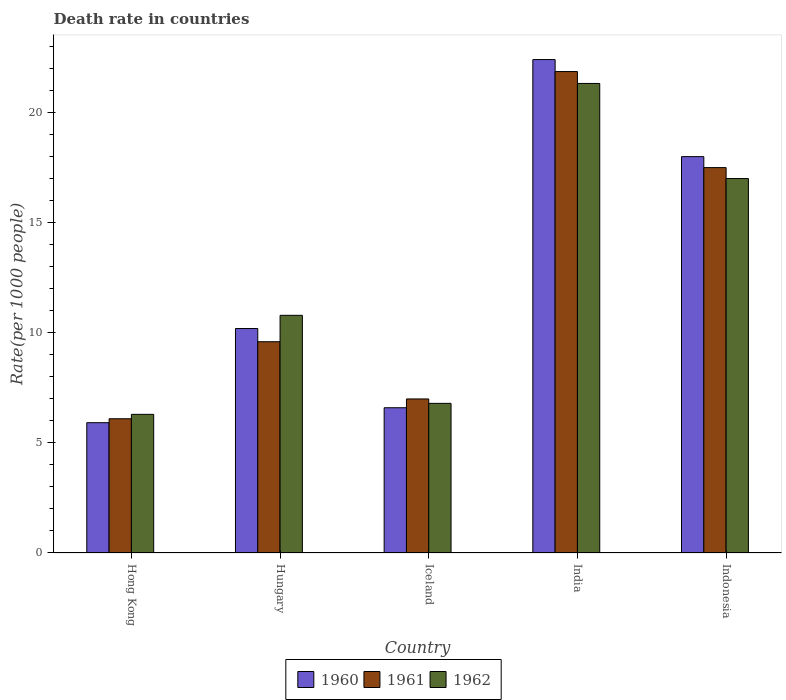How many different coloured bars are there?
Make the answer very short. 3. Are the number of bars per tick equal to the number of legend labels?
Your answer should be very brief. Yes. Are the number of bars on each tick of the X-axis equal?
Your answer should be compact. Yes. How many bars are there on the 5th tick from the left?
Ensure brevity in your answer.  3. How many bars are there on the 5th tick from the right?
Make the answer very short. 3. What is the label of the 4th group of bars from the left?
Provide a short and direct response. India. What is the death rate in 1961 in Indonesia?
Your answer should be very brief. 17.51. Across all countries, what is the maximum death rate in 1960?
Ensure brevity in your answer.  22.42. In which country was the death rate in 1961 minimum?
Your response must be concise. Hong Kong. What is the total death rate in 1962 in the graph?
Offer a very short reply. 62.25. What is the difference between the death rate in 1962 in Hong Kong and that in Iceland?
Give a very brief answer. -0.5. What is the average death rate in 1962 per country?
Offer a very short reply. 12.45. What is the difference between the death rate of/in 1962 and death rate of/in 1961 in Indonesia?
Make the answer very short. -0.5. In how many countries, is the death rate in 1961 greater than 8?
Your answer should be very brief. 3. What is the ratio of the death rate in 1961 in Hong Kong to that in Iceland?
Your response must be concise. 0.87. Is the death rate in 1960 in Hong Kong less than that in India?
Offer a very short reply. Yes. What is the difference between the highest and the second highest death rate in 1960?
Ensure brevity in your answer.  7.81. What is the difference between the highest and the lowest death rate in 1961?
Your answer should be very brief. 15.78. In how many countries, is the death rate in 1961 greater than the average death rate in 1961 taken over all countries?
Keep it short and to the point. 2. How many bars are there?
Offer a very short reply. 15. Are all the bars in the graph horizontal?
Give a very brief answer. No. What is the difference between two consecutive major ticks on the Y-axis?
Your response must be concise. 5. Are the values on the major ticks of Y-axis written in scientific E-notation?
Your answer should be compact. No. Where does the legend appear in the graph?
Offer a very short reply. Bottom center. How many legend labels are there?
Your answer should be compact. 3. How are the legend labels stacked?
Your answer should be very brief. Horizontal. What is the title of the graph?
Your response must be concise. Death rate in countries. What is the label or title of the X-axis?
Ensure brevity in your answer.  Country. What is the label or title of the Y-axis?
Offer a very short reply. Rate(per 1000 people). What is the Rate(per 1000 people) of 1960 in Hong Kong?
Give a very brief answer. 5.92. What is the Rate(per 1000 people) in 1961 in Hong Kong?
Keep it short and to the point. 6.1. What is the Rate(per 1000 people) in 1960 in Hungary?
Offer a very short reply. 10.2. What is the Rate(per 1000 people) in 1961 in Hungary?
Your response must be concise. 9.6. What is the Rate(per 1000 people) of 1962 in Hungary?
Give a very brief answer. 10.8. What is the Rate(per 1000 people) in 1961 in Iceland?
Your answer should be compact. 7. What is the Rate(per 1000 people) in 1962 in Iceland?
Your response must be concise. 6.8. What is the Rate(per 1000 people) of 1960 in India?
Your answer should be very brief. 22.42. What is the Rate(per 1000 people) in 1961 in India?
Make the answer very short. 21.88. What is the Rate(per 1000 people) of 1962 in India?
Offer a terse response. 21.34. What is the Rate(per 1000 people) of 1960 in Indonesia?
Provide a short and direct response. 18.01. What is the Rate(per 1000 people) of 1961 in Indonesia?
Give a very brief answer. 17.51. What is the Rate(per 1000 people) of 1962 in Indonesia?
Make the answer very short. 17.02. Across all countries, what is the maximum Rate(per 1000 people) in 1960?
Keep it short and to the point. 22.42. Across all countries, what is the maximum Rate(per 1000 people) of 1961?
Offer a very short reply. 21.88. Across all countries, what is the maximum Rate(per 1000 people) in 1962?
Provide a short and direct response. 21.34. Across all countries, what is the minimum Rate(per 1000 people) in 1960?
Offer a terse response. 5.92. Across all countries, what is the minimum Rate(per 1000 people) of 1961?
Keep it short and to the point. 6.1. Across all countries, what is the minimum Rate(per 1000 people) of 1962?
Your answer should be very brief. 6.3. What is the total Rate(per 1000 people) in 1960 in the graph?
Give a very brief answer. 63.16. What is the total Rate(per 1000 people) of 1961 in the graph?
Keep it short and to the point. 62.09. What is the total Rate(per 1000 people) in 1962 in the graph?
Offer a terse response. 62.25. What is the difference between the Rate(per 1000 people) in 1960 in Hong Kong and that in Hungary?
Provide a succinct answer. -4.28. What is the difference between the Rate(per 1000 people) of 1960 in Hong Kong and that in Iceland?
Ensure brevity in your answer.  -0.68. What is the difference between the Rate(per 1000 people) in 1961 in Hong Kong and that in Iceland?
Provide a succinct answer. -0.9. What is the difference between the Rate(per 1000 people) of 1962 in Hong Kong and that in Iceland?
Give a very brief answer. -0.5. What is the difference between the Rate(per 1000 people) in 1960 in Hong Kong and that in India?
Your response must be concise. -16.5. What is the difference between the Rate(per 1000 people) in 1961 in Hong Kong and that in India?
Your answer should be compact. -15.78. What is the difference between the Rate(per 1000 people) in 1962 in Hong Kong and that in India?
Your response must be concise. -15.04. What is the difference between the Rate(per 1000 people) in 1960 in Hong Kong and that in Indonesia?
Your answer should be very brief. -12.09. What is the difference between the Rate(per 1000 people) of 1961 in Hong Kong and that in Indonesia?
Offer a very short reply. -11.41. What is the difference between the Rate(per 1000 people) of 1962 in Hong Kong and that in Indonesia?
Provide a short and direct response. -10.72. What is the difference between the Rate(per 1000 people) in 1960 in Hungary and that in Iceland?
Your answer should be compact. 3.6. What is the difference between the Rate(per 1000 people) of 1961 in Hungary and that in Iceland?
Ensure brevity in your answer.  2.6. What is the difference between the Rate(per 1000 people) in 1962 in Hungary and that in Iceland?
Provide a short and direct response. 4. What is the difference between the Rate(per 1000 people) of 1960 in Hungary and that in India?
Give a very brief answer. -12.22. What is the difference between the Rate(per 1000 people) in 1961 in Hungary and that in India?
Your answer should be compact. -12.28. What is the difference between the Rate(per 1000 people) in 1962 in Hungary and that in India?
Your answer should be compact. -10.54. What is the difference between the Rate(per 1000 people) of 1960 in Hungary and that in Indonesia?
Offer a very short reply. -7.81. What is the difference between the Rate(per 1000 people) of 1961 in Hungary and that in Indonesia?
Provide a succinct answer. -7.91. What is the difference between the Rate(per 1000 people) in 1962 in Hungary and that in Indonesia?
Offer a terse response. -6.22. What is the difference between the Rate(per 1000 people) of 1960 in Iceland and that in India?
Provide a short and direct response. -15.82. What is the difference between the Rate(per 1000 people) in 1961 in Iceland and that in India?
Provide a short and direct response. -14.88. What is the difference between the Rate(per 1000 people) of 1962 in Iceland and that in India?
Give a very brief answer. -14.54. What is the difference between the Rate(per 1000 people) in 1960 in Iceland and that in Indonesia?
Your answer should be very brief. -11.41. What is the difference between the Rate(per 1000 people) of 1961 in Iceland and that in Indonesia?
Make the answer very short. -10.51. What is the difference between the Rate(per 1000 people) of 1962 in Iceland and that in Indonesia?
Your answer should be compact. -10.22. What is the difference between the Rate(per 1000 people) in 1960 in India and that in Indonesia?
Ensure brevity in your answer.  4.41. What is the difference between the Rate(per 1000 people) of 1961 in India and that in Indonesia?
Your answer should be compact. 4.36. What is the difference between the Rate(per 1000 people) of 1962 in India and that in Indonesia?
Your answer should be compact. 4.32. What is the difference between the Rate(per 1000 people) of 1960 in Hong Kong and the Rate(per 1000 people) of 1961 in Hungary?
Your answer should be compact. -3.68. What is the difference between the Rate(per 1000 people) of 1960 in Hong Kong and the Rate(per 1000 people) of 1962 in Hungary?
Your answer should be very brief. -4.88. What is the difference between the Rate(per 1000 people) of 1960 in Hong Kong and the Rate(per 1000 people) of 1961 in Iceland?
Give a very brief answer. -1.08. What is the difference between the Rate(per 1000 people) of 1960 in Hong Kong and the Rate(per 1000 people) of 1962 in Iceland?
Offer a terse response. -0.88. What is the difference between the Rate(per 1000 people) in 1960 in Hong Kong and the Rate(per 1000 people) in 1961 in India?
Provide a succinct answer. -15.96. What is the difference between the Rate(per 1000 people) in 1960 in Hong Kong and the Rate(per 1000 people) in 1962 in India?
Offer a very short reply. -15.42. What is the difference between the Rate(per 1000 people) of 1961 in Hong Kong and the Rate(per 1000 people) of 1962 in India?
Your answer should be compact. -15.24. What is the difference between the Rate(per 1000 people) of 1960 in Hong Kong and the Rate(per 1000 people) of 1961 in Indonesia?
Keep it short and to the point. -11.59. What is the difference between the Rate(per 1000 people) in 1960 in Hong Kong and the Rate(per 1000 people) in 1962 in Indonesia?
Give a very brief answer. -11.1. What is the difference between the Rate(per 1000 people) in 1961 in Hong Kong and the Rate(per 1000 people) in 1962 in Indonesia?
Your answer should be very brief. -10.92. What is the difference between the Rate(per 1000 people) in 1960 in Hungary and the Rate(per 1000 people) in 1962 in Iceland?
Make the answer very short. 3.4. What is the difference between the Rate(per 1000 people) of 1960 in Hungary and the Rate(per 1000 people) of 1961 in India?
Ensure brevity in your answer.  -11.68. What is the difference between the Rate(per 1000 people) in 1960 in Hungary and the Rate(per 1000 people) in 1962 in India?
Provide a short and direct response. -11.14. What is the difference between the Rate(per 1000 people) of 1961 in Hungary and the Rate(per 1000 people) of 1962 in India?
Your answer should be very brief. -11.74. What is the difference between the Rate(per 1000 people) of 1960 in Hungary and the Rate(per 1000 people) of 1961 in Indonesia?
Give a very brief answer. -7.31. What is the difference between the Rate(per 1000 people) of 1960 in Hungary and the Rate(per 1000 people) of 1962 in Indonesia?
Your response must be concise. -6.82. What is the difference between the Rate(per 1000 people) of 1961 in Hungary and the Rate(per 1000 people) of 1962 in Indonesia?
Provide a short and direct response. -7.42. What is the difference between the Rate(per 1000 people) in 1960 in Iceland and the Rate(per 1000 people) in 1961 in India?
Ensure brevity in your answer.  -15.28. What is the difference between the Rate(per 1000 people) of 1960 in Iceland and the Rate(per 1000 people) of 1962 in India?
Provide a succinct answer. -14.74. What is the difference between the Rate(per 1000 people) of 1961 in Iceland and the Rate(per 1000 people) of 1962 in India?
Offer a very short reply. -14.34. What is the difference between the Rate(per 1000 people) in 1960 in Iceland and the Rate(per 1000 people) in 1961 in Indonesia?
Keep it short and to the point. -10.91. What is the difference between the Rate(per 1000 people) of 1960 in Iceland and the Rate(per 1000 people) of 1962 in Indonesia?
Your answer should be compact. -10.42. What is the difference between the Rate(per 1000 people) in 1961 in Iceland and the Rate(per 1000 people) in 1962 in Indonesia?
Offer a very short reply. -10.02. What is the difference between the Rate(per 1000 people) of 1960 in India and the Rate(per 1000 people) of 1961 in Indonesia?
Provide a short and direct response. 4.91. What is the difference between the Rate(per 1000 people) in 1960 in India and the Rate(per 1000 people) in 1962 in Indonesia?
Your answer should be very brief. 5.41. What is the difference between the Rate(per 1000 people) in 1961 in India and the Rate(per 1000 people) in 1962 in Indonesia?
Offer a very short reply. 4.86. What is the average Rate(per 1000 people) in 1960 per country?
Make the answer very short. 12.63. What is the average Rate(per 1000 people) of 1961 per country?
Make the answer very short. 12.42. What is the average Rate(per 1000 people) in 1962 per country?
Provide a short and direct response. 12.45. What is the difference between the Rate(per 1000 people) of 1960 and Rate(per 1000 people) of 1961 in Hong Kong?
Your answer should be compact. -0.18. What is the difference between the Rate(per 1000 people) in 1960 and Rate(per 1000 people) in 1962 in Hong Kong?
Ensure brevity in your answer.  -0.38. What is the difference between the Rate(per 1000 people) of 1961 and Rate(per 1000 people) of 1962 in Hong Kong?
Offer a very short reply. -0.2. What is the difference between the Rate(per 1000 people) of 1960 and Rate(per 1000 people) of 1961 in Hungary?
Your answer should be very brief. 0.6. What is the difference between the Rate(per 1000 people) of 1961 and Rate(per 1000 people) of 1962 in Hungary?
Provide a short and direct response. -1.2. What is the difference between the Rate(per 1000 people) in 1960 and Rate(per 1000 people) in 1961 in Iceland?
Offer a terse response. -0.4. What is the difference between the Rate(per 1000 people) in 1961 and Rate(per 1000 people) in 1962 in Iceland?
Your answer should be very brief. 0.2. What is the difference between the Rate(per 1000 people) in 1960 and Rate(per 1000 people) in 1961 in India?
Ensure brevity in your answer.  0.55. What is the difference between the Rate(per 1000 people) in 1960 and Rate(per 1000 people) in 1962 in India?
Ensure brevity in your answer.  1.09. What is the difference between the Rate(per 1000 people) of 1961 and Rate(per 1000 people) of 1962 in India?
Give a very brief answer. 0.54. What is the difference between the Rate(per 1000 people) of 1960 and Rate(per 1000 people) of 1961 in Indonesia?
Offer a terse response. 0.5. What is the difference between the Rate(per 1000 people) of 1960 and Rate(per 1000 people) of 1962 in Indonesia?
Keep it short and to the point. 0.99. What is the difference between the Rate(per 1000 people) in 1961 and Rate(per 1000 people) in 1962 in Indonesia?
Offer a terse response. 0.5. What is the ratio of the Rate(per 1000 people) in 1960 in Hong Kong to that in Hungary?
Keep it short and to the point. 0.58. What is the ratio of the Rate(per 1000 people) of 1961 in Hong Kong to that in Hungary?
Ensure brevity in your answer.  0.64. What is the ratio of the Rate(per 1000 people) in 1962 in Hong Kong to that in Hungary?
Your answer should be compact. 0.58. What is the ratio of the Rate(per 1000 people) in 1960 in Hong Kong to that in Iceland?
Provide a succinct answer. 0.9. What is the ratio of the Rate(per 1000 people) of 1961 in Hong Kong to that in Iceland?
Offer a terse response. 0.87. What is the ratio of the Rate(per 1000 people) of 1962 in Hong Kong to that in Iceland?
Your response must be concise. 0.93. What is the ratio of the Rate(per 1000 people) in 1960 in Hong Kong to that in India?
Your answer should be very brief. 0.26. What is the ratio of the Rate(per 1000 people) of 1961 in Hong Kong to that in India?
Your response must be concise. 0.28. What is the ratio of the Rate(per 1000 people) in 1962 in Hong Kong to that in India?
Your answer should be very brief. 0.3. What is the ratio of the Rate(per 1000 people) in 1960 in Hong Kong to that in Indonesia?
Your response must be concise. 0.33. What is the ratio of the Rate(per 1000 people) of 1961 in Hong Kong to that in Indonesia?
Keep it short and to the point. 0.35. What is the ratio of the Rate(per 1000 people) of 1962 in Hong Kong to that in Indonesia?
Make the answer very short. 0.37. What is the ratio of the Rate(per 1000 people) of 1960 in Hungary to that in Iceland?
Keep it short and to the point. 1.55. What is the ratio of the Rate(per 1000 people) in 1961 in Hungary to that in Iceland?
Offer a terse response. 1.37. What is the ratio of the Rate(per 1000 people) of 1962 in Hungary to that in Iceland?
Keep it short and to the point. 1.59. What is the ratio of the Rate(per 1000 people) in 1960 in Hungary to that in India?
Offer a very short reply. 0.45. What is the ratio of the Rate(per 1000 people) in 1961 in Hungary to that in India?
Give a very brief answer. 0.44. What is the ratio of the Rate(per 1000 people) of 1962 in Hungary to that in India?
Offer a terse response. 0.51. What is the ratio of the Rate(per 1000 people) of 1960 in Hungary to that in Indonesia?
Ensure brevity in your answer.  0.57. What is the ratio of the Rate(per 1000 people) of 1961 in Hungary to that in Indonesia?
Make the answer very short. 0.55. What is the ratio of the Rate(per 1000 people) of 1962 in Hungary to that in Indonesia?
Your response must be concise. 0.63. What is the ratio of the Rate(per 1000 people) in 1960 in Iceland to that in India?
Your response must be concise. 0.29. What is the ratio of the Rate(per 1000 people) in 1961 in Iceland to that in India?
Your answer should be compact. 0.32. What is the ratio of the Rate(per 1000 people) in 1962 in Iceland to that in India?
Give a very brief answer. 0.32. What is the ratio of the Rate(per 1000 people) of 1960 in Iceland to that in Indonesia?
Make the answer very short. 0.37. What is the ratio of the Rate(per 1000 people) in 1961 in Iceland to that in Indonesia?
Your response must be concise. 0.4. What is the ratio of the Rate(per 1000 people) of 1962 in Iceland to that in Indonesia?
Ensure brevity in your answer.  0.4. What is the ratio of the Rate(per 1000 people) of 1960 in India to that in Indonesia?
Give a very brief answer. 1.25. What is the ratio of the Rate(per 1000 people) of 1961 in India to that in Indonesia?
Keep it short and to the point. 1.25. What is the ratio of the Rate(per 1000 people) in 1962 in India to that in Indonesia?
Offer a terse response. 1.25. What is the difference between the highest and the second highest Rate(per 1000 people) of 1960?
Offer a very short reply. 4.41. What is the difference between the highest and the second highest Rate(per 1000 people) of 1961?
Keep it short and to the point. 4.36. What is the difference between the highest and the second highest Rate(per 1000 people) of 1962?
Provide a succinct answer. 4.32. What is the difference between the highest and the lowest Rate(per 1000 people) of 1960?
Your answer should be compact. 16.5. What is the difference between the highest and the lowest Rate(per 1000 people) of 1961?
Your response must be concise. 15.78. What is the difference between the highest and the lowest Rate(per 1000 people) in 1962?
Provide a succinct answer. 15.04. 